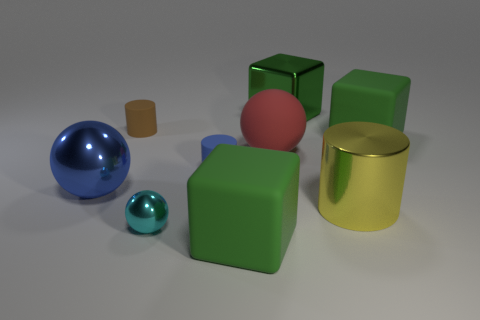Subtract all cylinders. How many objects are left? 6 Add 7 small purple shiny cylinders. How many small purple shiny cylinders exist? 7 Subtract 0 brown balls. How many objects are left? 9 Subtract all big metallic cylinders. Subtract all yellow shiny cylinders. How many objects are left? 7 Add 9 green metal things. How many green metal things are left? 10 